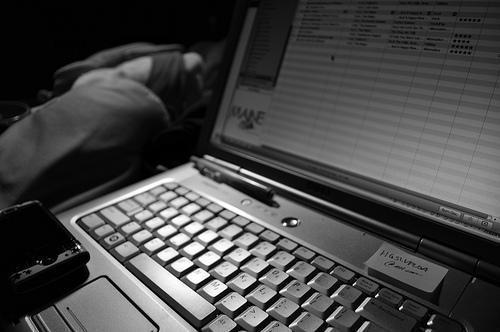How many laptops are visible?
Give a very brief answer. 1. 